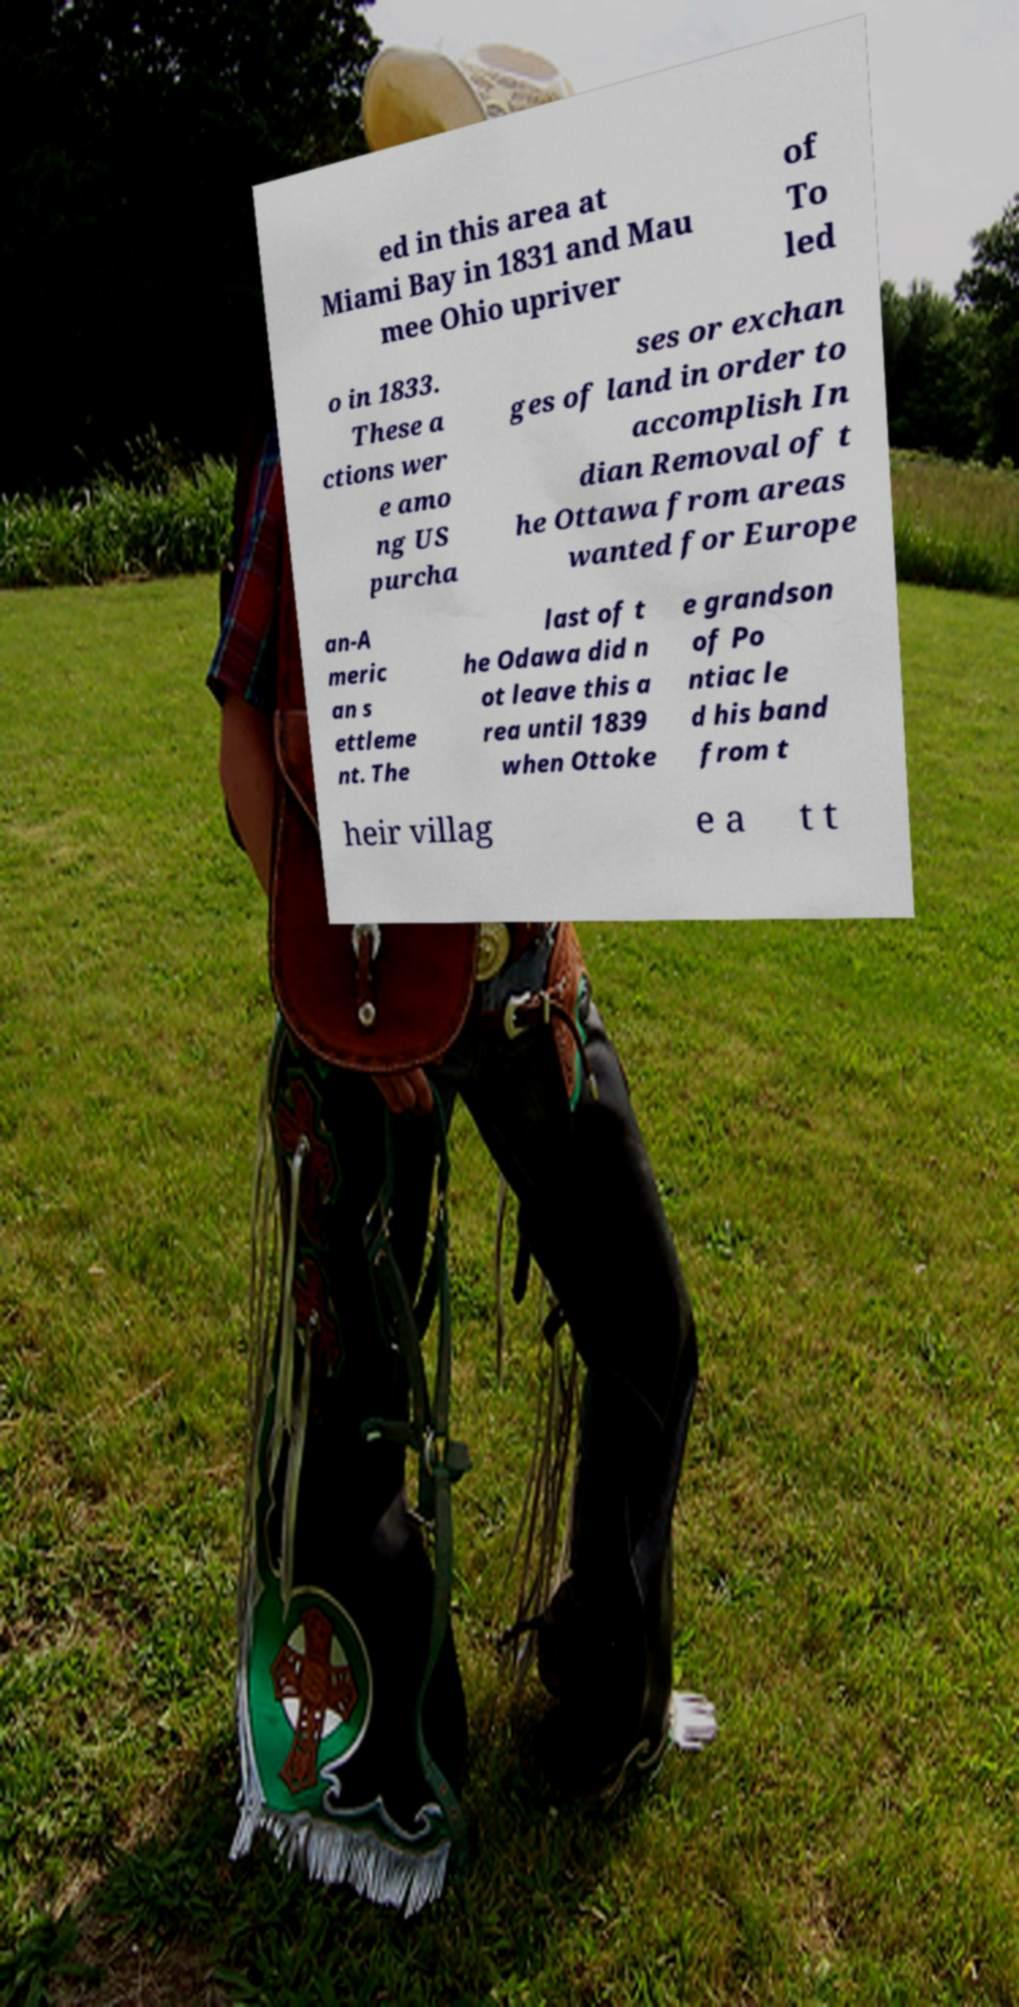I need the written content from this picture converted into text. Can you do that? ed in this area at Miami Bay in 1831 and Mau mee Ohio upriver of To led o in 1833. These a ctions wer e amo ng US purcha ses or exchan ges of land in order to accomplish In dian Removal of t he Ottawa from areas wanted for Europe an-A meric an s ettleme nt. The last of t he Odawa did n ot leave this a rea until 1839 when Ottoke e grandson of Po ntiac le d his band from t heir villag e a t t 